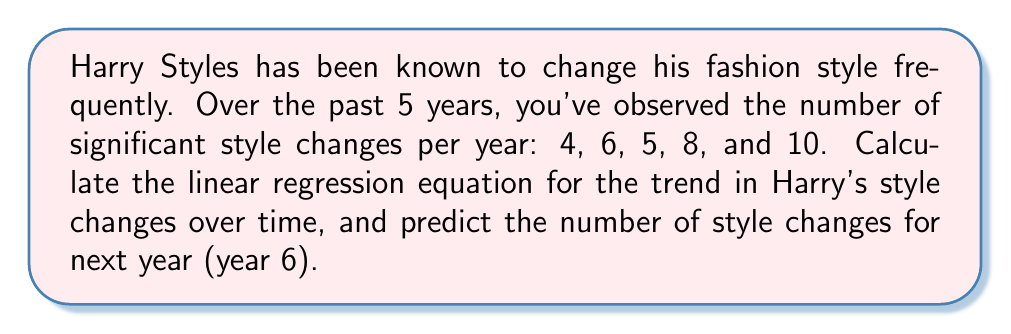Show me your answer to this math problem. To find the linear regression equation and make a prediction, we'll follow these steps:

1. Let x represent the year (1-5) and y represent the number of style changes.

2. Calculate the means:
   $\bar{x} = \frac{1+2+3+4+5}{5} = 3$
   $\bar{y} = \frac{4+6+5+8+10}{5} = 6.6$

3. Calculate the slope (m) using the formula:
   $m = \frac{\sum(x-\bar{x})(y-\bar{y})}{\sum(x-\bar{x})^2}$

   $\sum(x-\bar{x})(y-\bar{y}) = (-2)(-2.6) + (-1)(-0.6) + (0)(-1.6) + (1)(1.4) + (2)(3.4) = 14$
   $\sum(x-\bar{x})^2 = (-2)^2 + (-1)^2 + 0^2 + 1^2 + 2^2 = 10$

   $m = \frac{14}{10} = 1.4$

4. Calculate the y-intercept (b) using the formula:
   $b = \bar{y} - m\bar{x} = 6.6 - 1.4(3) = 2.4$

5. The linear regression equation is:
   $y = 1.4x + 2.4$

6. To predict the number of style changes for year 6, substitute x = 6:
   $y = 1.4(6) + 2.4 = 10.8$
Answer: $y = 1.4x + 2.4$; 10.8 style changes 